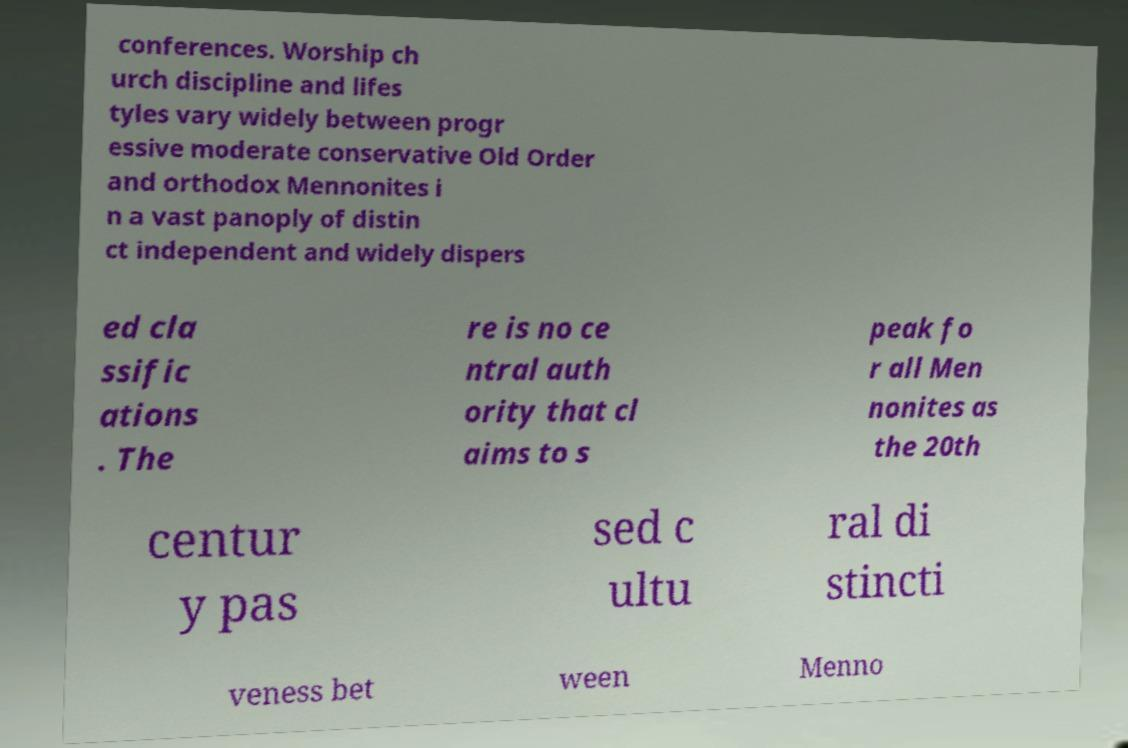Please identify and transcribe the text found in this image. conferences. Worship ch urch discipline and lifes tyles vary widely between progr essive moderate conservative Old Order and orthodox Mennonites i n a vast panoply of distin ct independent and widely dispers ed cla ssific ations . The re is no ce ntral auth ority that cl aims to s peak fo r all Men nonites as the 20th centur y pas sed c ultu ral di stincti veness bet ween Menno 